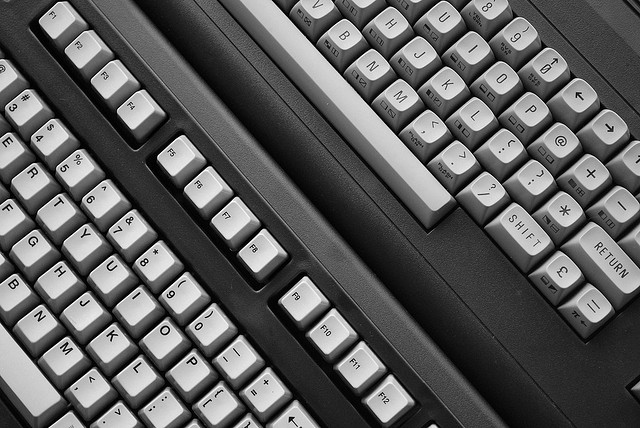What might be the historical significance of this item? Typewriters had a significant role in business, literature, and communications from the late 19th century until they were gradually supplanted by personal computers and word processors in the 1980s and 1990s. They revolutionized the process of writing and distributing printed material. 